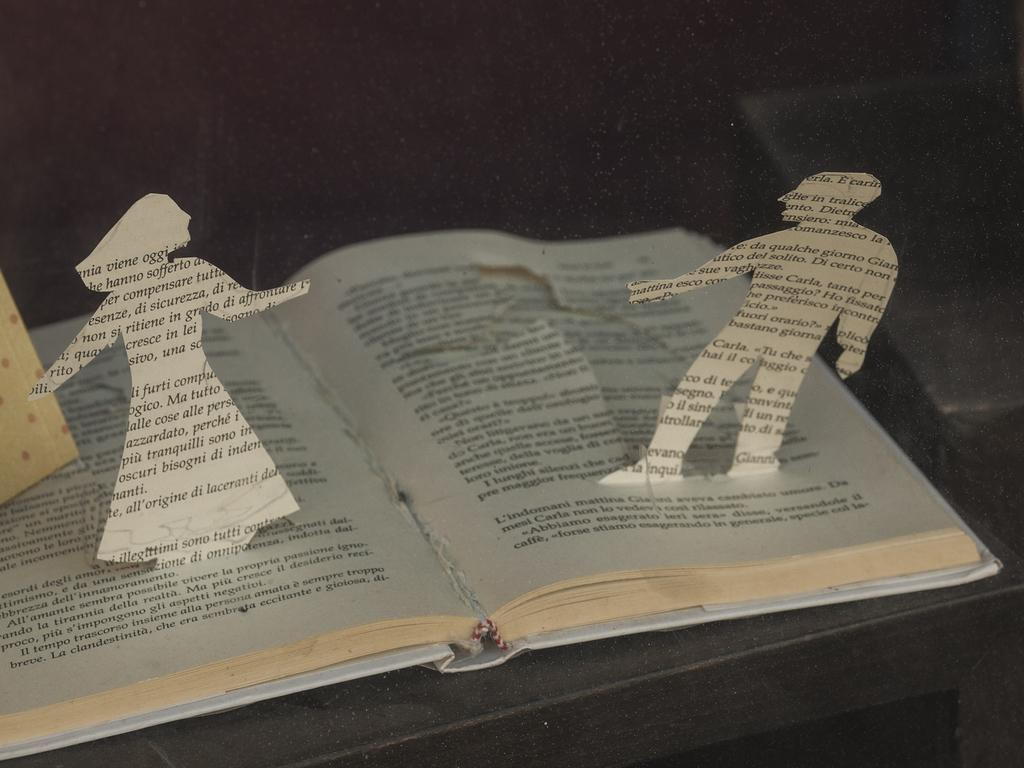<image>
Present a compact description of the photo's key features. The word viene appears on the paper cutout of a women. 